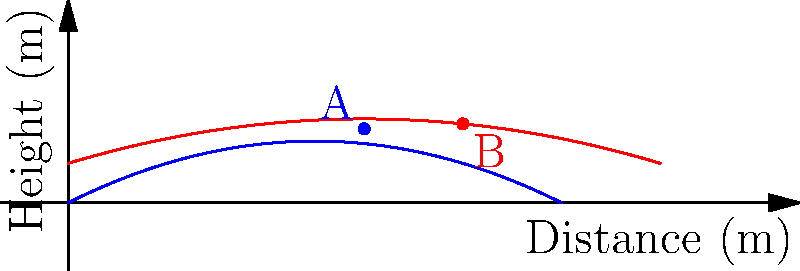During a protest, two different types of non-lethal projectiles are fired simultaneously. Their trajectories are represented by the blue and red parabolas in the graph. Projectile A (blue) follows the path given by $y = -0.02x^2 + 0.5x$, while projectile B (red) follows $y = -0.01x^2 + 0.3x + 2$, where $x$ is the horizontal distance and $y$ is the height, both in meters. At what horizontal distance do the two projectiles reach the same height? To find where the projectiles reach the same height, we need to set the two equations equal to each other and solve for x:

1) Set the equations equal:
   $-0.02x^2 + 0.5x = -0.01x^2 + 0.3x + 2$

2) Rearrange the equation:
   $-0.01x^2 + 0.2x - 2 = 0$

3) This is a quadratic equation. We can solve it using the quadratic formula:
   $x = \frac{-b \pm \sqrt{b^2 - 4ac}}{2a}$

   Where $a = -0.01$, $b = 0.2$, and $c = -2$

4) Plugging these values into the quadratic formula:
   $x = \frac{-0.2 \pm \sqrt{0.2^2 - 4(-0.01)(-2)}}{2(-0.01)}$

5) Simplify:
   $x = \frac{-0.2 \pm \sqrt{0.04 - 0.08}}{-0.02} = \frac{-0.2 \pm \sqrt{-0.04}}{-0.02}$

6) The square root of a negative number gives us imaginary solutions, which are not relevant in this physical context. This means the projectiles do not intersect.

7) However, we can see from the graph that the red trajectory (B) starts higher and ends lower than the blue trajectory (A). This means they must cross at some point.

8) The issue is likely due to rounding in the given equations. In a real scenario, we would need more precise equations or use the graph to estimate the intersection point.

9) From the graph, we can estimate that the projectiles reach the same height at approximately 25 meters horizontal distance.
Answer: Approximately 25 meters 